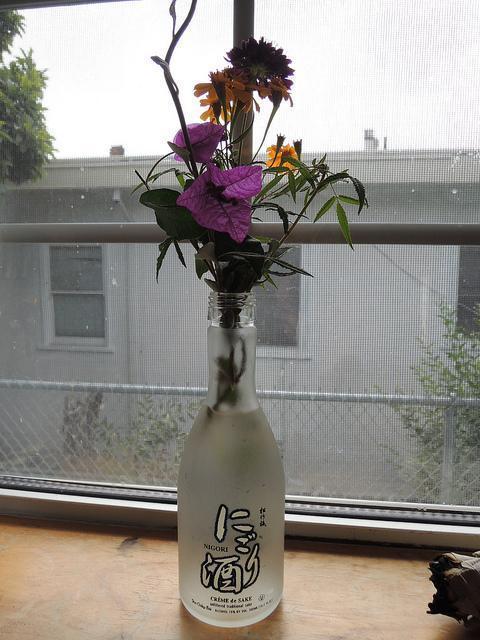How many potted plants are there?
Give a very brief answer. 1. 